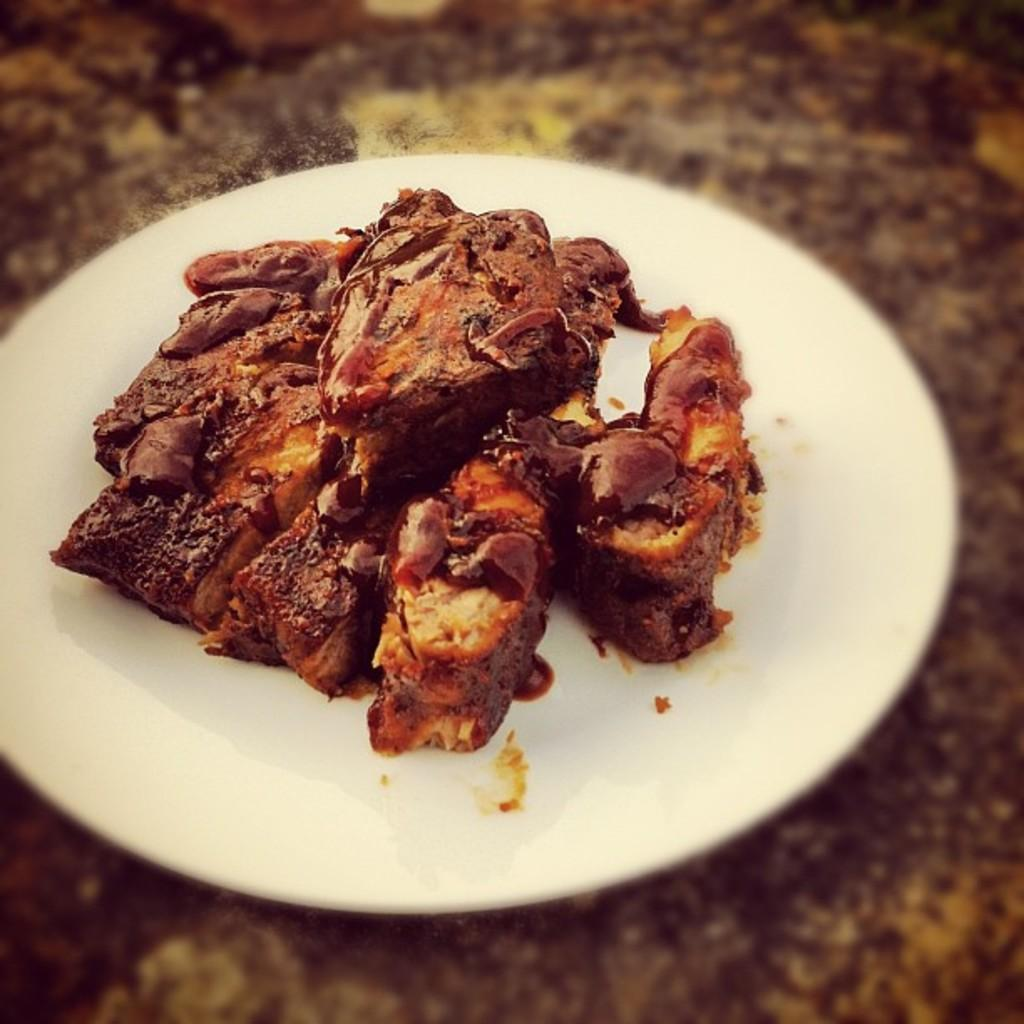What is present on the plate in the image? There is food in a plate in the image. What type of house is depicted in the image? There is no house present in the image; it only features food on a plate. What message of peace can be seen in the image? There is no message of peace present in the image; it only features food on a plate. What type of magical powers can be seen in the image? There is no magical power present in the image; it only features food on a plate. 